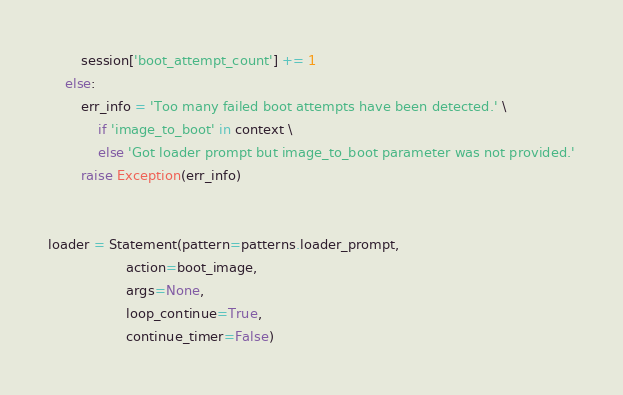<code> <loc_0><loc_0><loc_500><loc_500><_Python_>        session['boot_attempt_count'] += 1
    else:
        err_info = 'Too many failed boot attempts have been detected.' \
            if 'image_to_boot' in context \
            else 'Got loader prompt but image_to_boot parameter was not provided.'
        raise Exception(err_info)


loader = Statement(pattern=patterns.loader_prompt,
                   action=boot_image,
                   args=None,
                   loop_continue=True,
                   continue_timer=False)
</code> 